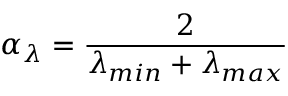Convert formula to latex. <formula><loc_0><loc_0><loc_500><loc_500>\alpha _ { \lambda } = \frac { 2 } { \lambda _ { \min } + \lambda _ { \max } }</formula> 